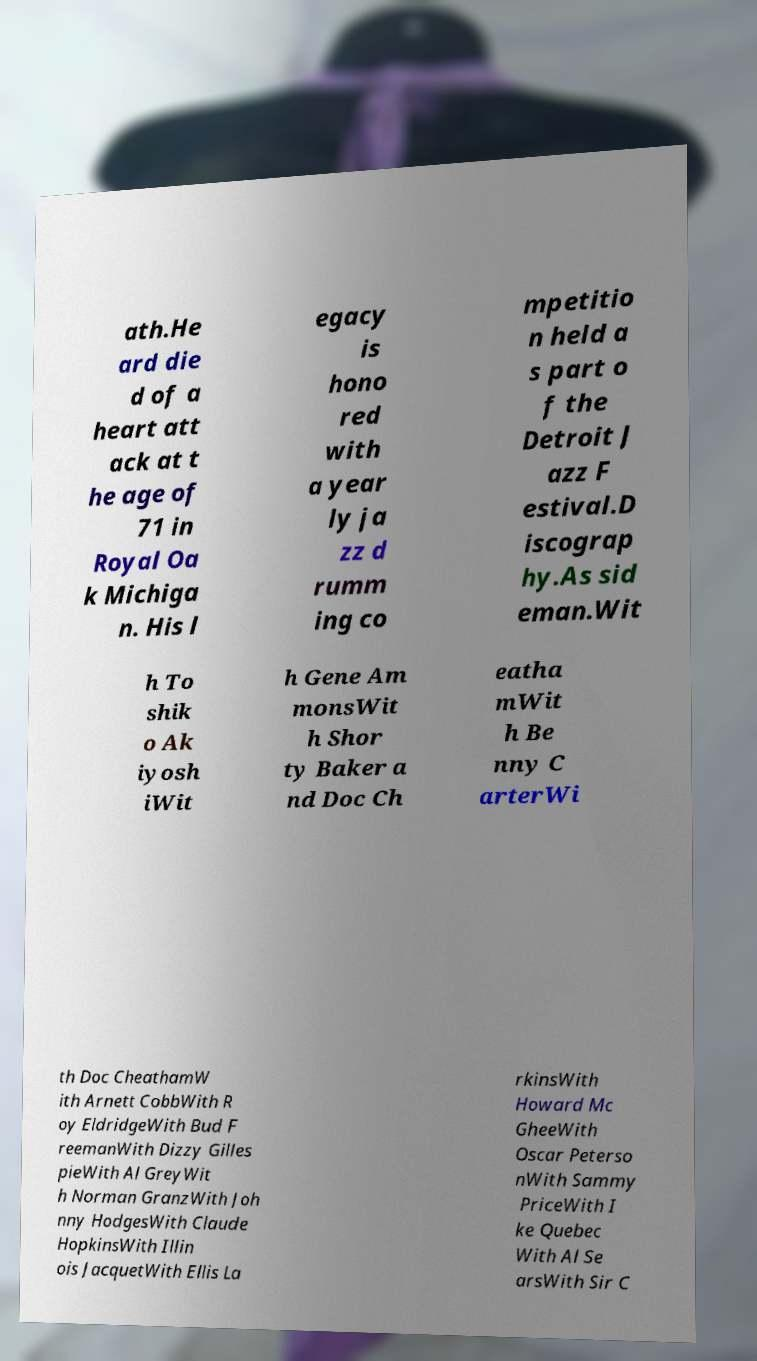What messages or text are displayed in this image? I need them in a readable, typed format. ath.He ard die d of a heart att ack at t he age of 71 in Royal Oa k Michiga n. His l egacy is hono red with a year ly ja zz d rumm ing co mpetitio n held a s part o f the Detroit J azz F estival.D iscograp hy.As sid eman.Wit h To shik o Ak iyosh iWit h Gene Am monsWit h Shor ty Baker a nd Doc Ch eatha mWit h Be nny C arterWi th Doc CheathamW ith Arnett CobbWith R oy EldridgeWith Bud F reemanWith Dizzy Gilles pieWith Al GreyWit h Norman GranzWith Joh nny HodgesWith Claude HopkinsWith Illin ois JacquetWith Ellis La rkinsWith Howard Mc GheeWith Oscar Peterso nWith Sammy PriceWith I ke Quebec With Al Se arsWith Sir C 